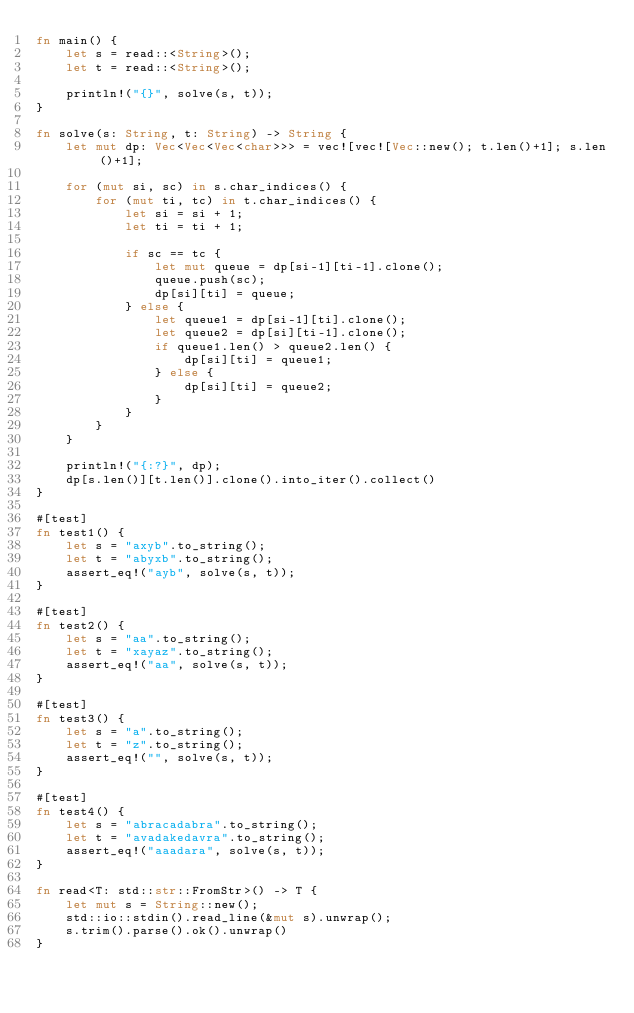<code> <loc_0><loc_0><loc_500><loc_500><_Rust_>fn main() {
    let s = read::<String>();
    let t = read::<String>();
    
    println!("{}", solve(s, t));
}

fn solve(s: String, t: String) -> String {
    let mut dp: Vec<Vec<Vec<char>>> = vec![vec![Vec::new(); t.len()+1]; s.len()+1];

    for (mut si, sc) in s.char_indices() {
        for (mut ti, tc) in t.char_indices() {
            let si = si + 1;
            let ti = ti + 1;

            if sc == tc {
                let mut queue = dp[si-1][ti-1].clone();
                queue.push(sc);
                dp[si][ti] = queue;
            } else {
                let queue1 = dp[si-1][ti].clone();
                let queue2 = dp[si][ti-1].clone();
                if queue1.len() > queue2.len() {
                    dp[si][ti] = queue1;
                } else {
                    dp[si][ti] = queue2;
                }
            }
        }
    }

    println!("{:?}", dp);
    dp[s.len()][t.len()].clone().into_iter().collect()
}

#[test]
fn test1() {
    let s = "axyb".to_string();
    let t = "abyxb".to_string();
    assert_eq!("ayb", solve(s, t));
}

#[test]
fn test2() {
    let s = "aa".to_string();
    let t = "xayaz".to_string();
    assert_eq!("aa", solve(s, t));
}

#[test]
fn test3() {
    let s = "a".to_string();
    let t = "z".to_string();
    assert_eq!("", solve(s, t));
}

#[test]
fn test4() {
    let s = "abracadabra".to_string();
    let t = "avadakedavra".to_string();
    assert_eq!("aaadara", solve(s, t));
}

fn read<T: std::str::FromStr>() -> T {
    let mut s = String::new();
    std::io::stdin().read_line(&mut s).unwrap();
    s.trim().parse().ok().unwrap()
}
</code> 